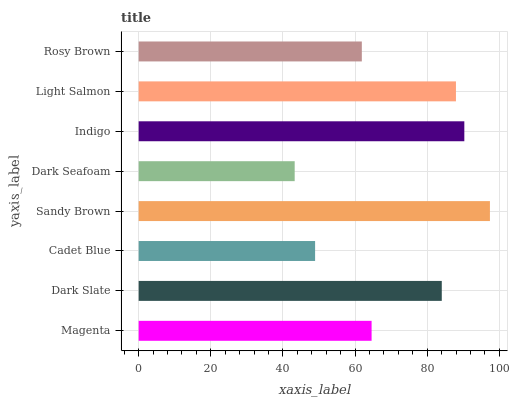Is Dark Seafoam the minimum?
Answer yes or no. Yes. Is Sandy Brown the maximum?
Answer yes or no. Yes. Is Dark Slate the minimum?
Answer yes or no. No. Is Dark Slate the maximum?
Answer yes or no. No. Is Dark Slate greater than Magenta?
Answer yes or no. Yes. Is Magenta less than Dark Slate?
Answer yes or no. Yes. Is Magenta greater than Dark Slate?
Answer yes or no. No. Is Dark Slate less than Magenta?
Answer yes or no. No. Is Dark Slate the high median?
Answer yes or no. Yes. Is Magenta the low median?
Answer yes or no. Yes. Is Sandy Brown the high median?
Answer yes or no. No. Is Cadet Blue the low median?
Answer yes or no. No. 